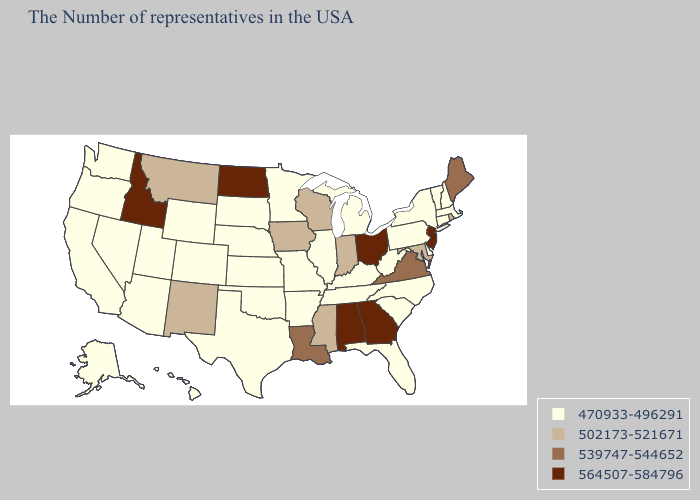Does Oklahoma have a lower value than Washington?
Short answer required. No. Name the states that have a value in the range 564507-584796?
Give a very brief answer. New Jersey, Ohio, Georgia, Alabama, North Dakota, Idaho. What is the value of Kentucky?
Keep it brief. 470933-496291. What is the value of Arkansas?
Concise answer only. 470933-496291. Name the states that have a value in the range 470933-496291?
Write a very short answer. Massachusetts, New Hampshire, Vermont, Connecticut, New York, Delaware, Pennsylvania, North Carolina, South Carolina, West Virginia, Florida, Michigan, Kentucky, Tennessee, Illinois, Missouri, Arkansas, Minnesota, Kansas, Nebraska, Oklahoma, Texas, South Dakota, Wyoming, Colorado, Utah, Arizona, Nevada, California, Washington, Oregon, Alaska, Hawaii. Which states have the lowest value in the USA?
Quick response, please. Massachusetts, New Hampshire, Vermont, Connecticut, New York, Delaware, Pennsylvania, North Carolina, South Carolina, West Virginia, Florida, Michigan, Kentucky, Tennessee, Illinois, Missouri, Arkansas, Minnesota, Kansas, Nebraska, Oklahoma, Texas, South Dakota, Wyoming, Colorado, Utah, Arizona, Nevada, California, Washington, Oregon, Alaska, Hawaii. Name the states that have a value in the range 539747-544652?
Give a very brief answer. Maine, Virginia, Louisiana. What is the value of Tennessee?
Short answer required. 470933-496291. Name the states that have a value in the range 470933-496291?
Be succinct. Massachusetts, New Hampshire, Vermont, Connecticut, New York, Delaware, Pennsylvania, North Carolina, South Carolina, West Virginia, Florida, Michigan, Kentucky, Tennessee, Illinois, Missouri, Arkansas, Minnesota, Kansas, Nebraska, Oklahoma, Texas, South Dakota, Wyoming, Colorado, Utah, Arizona, Nevada, California, Washington, Oregon, Alaska, Hawaii. Name the states that have a value in the range 539747-544652?
Give a very brief answer. Maine, Virginia, Louisiana. What is the highest value in the USA?
Concise answer only. 564507-584796. Name the states that have a value in the range 470933-496291?
Quick response, please. Massachusetts, New Hampshire, Vermont, Connecticut, New York, Delaware, Pennsylvania, North Carolina, South Carolina, West Virginia, Florida, Michigan, Kentucky, Tennessee, Illinois, Missouri, Arkansas, Minnesota, Kansas, Nebraska, Oklahoma, Texas, South Dakota, Wyoming, Colorado, Utah, Arizona, Nevada, California, Washington, Oregon, Alaska, Hawaii. Does Colorado have the same value as Hawaii?
Quick response, please. Yes. What is the lowest value in the West?
Be succinct. 470933-496291. What is the value of Colorado?
Write a very short answer. 470933-496291. 